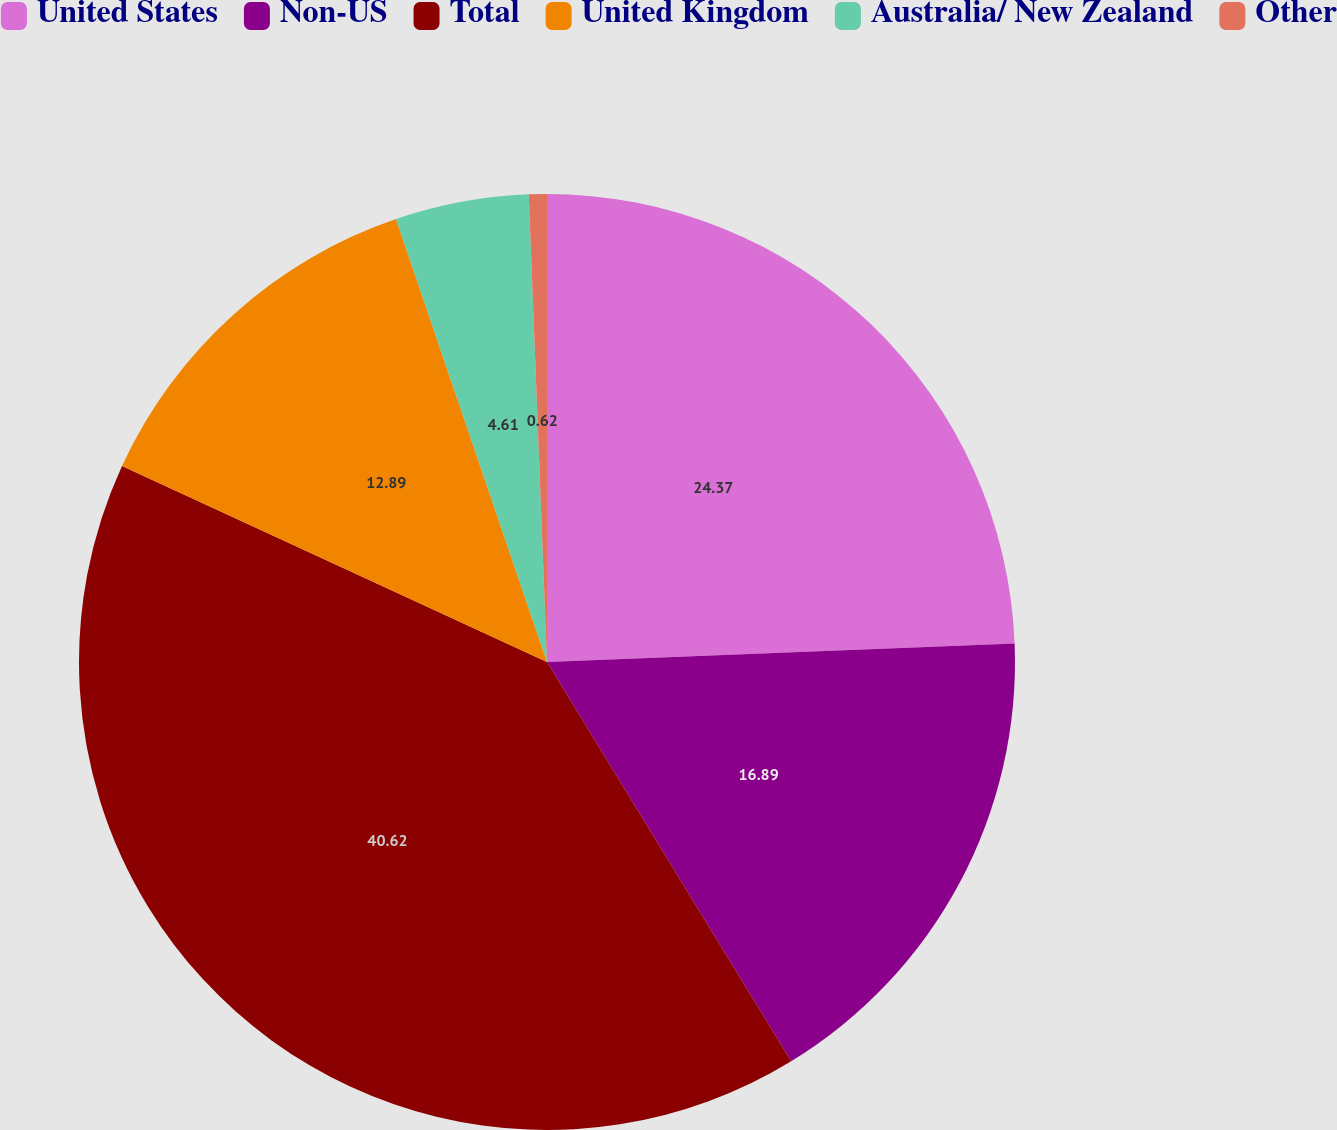Convert chart. <chart><loc_0><loc_0><loc_500><loc_500><pie_chart><fcel>United States<fcel>Non-US<fcel>Total<fcel>United Kingdom<fcel>Australia/ New Zealand<fcel>Other<nl><fcel>24.37%<fcel>16.89%<fcel>40.61%<fcel>12.89%<fcel>4.61%<fcel>0.62%<nl></chart> 